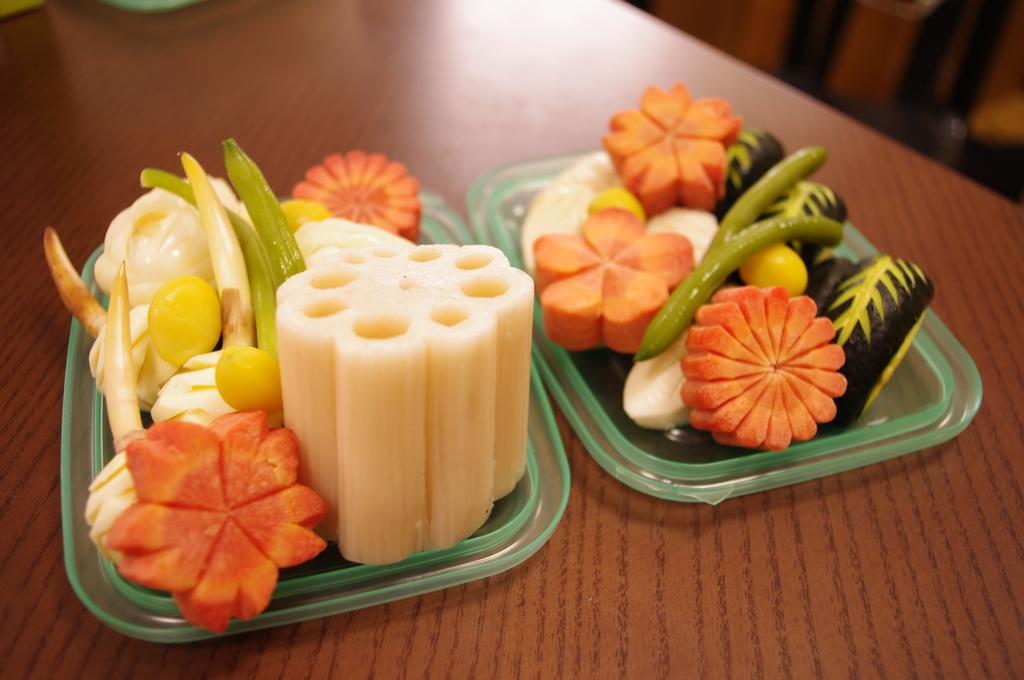How many plates are visible in the image? There are two plates in the image. What is on the plates? The plates have food items on them. Where are the plates located? The plates are on a table. Can you see any veins in the food on the plates? There are no veins visible in the food on the plates, as veins are not a part of food items. 